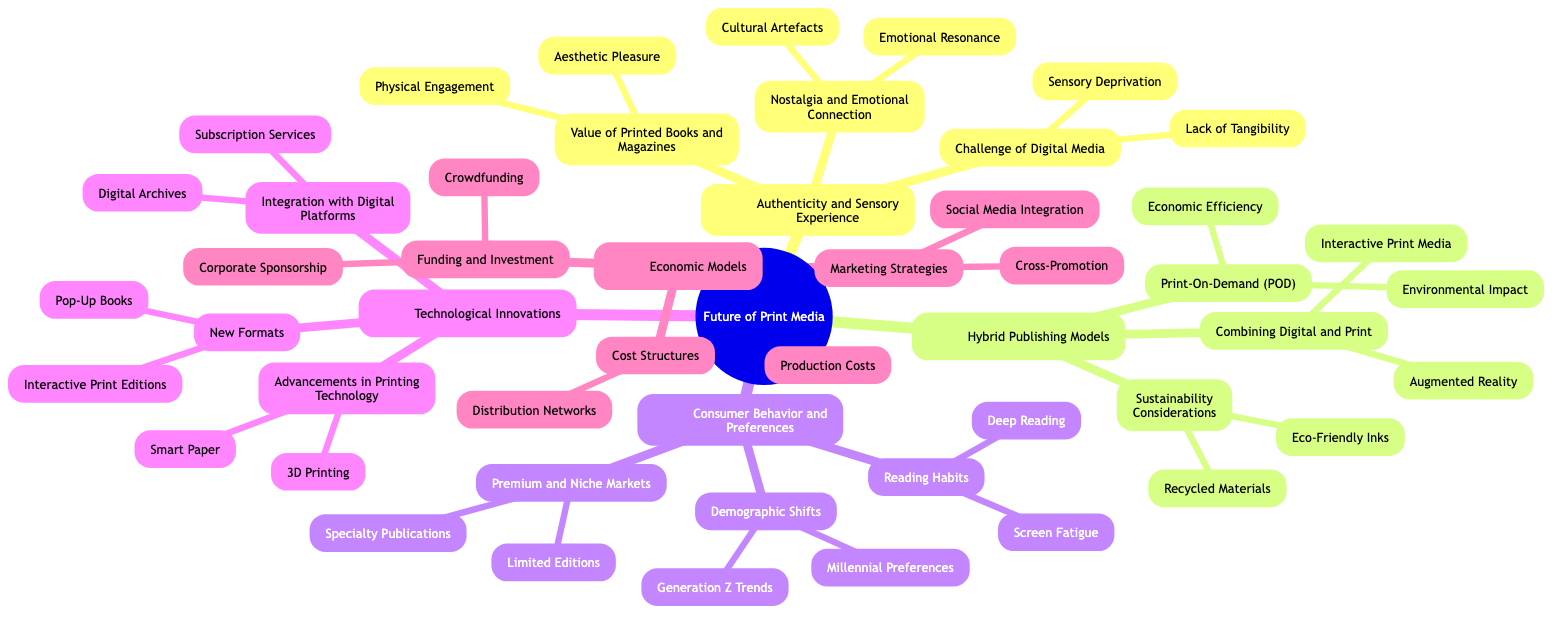What are the subelements under "Challenge of Digital Media"? The diagram shows the subelements beneath "Challenge of Digital Media" as "Lack of Tangibility" and "Sensory Deprivation".
Answer: Lack of Tangibility, Sensory Deprivation How many main categories does the concept map have? The concept map presents five main categories: Authenticity and Sensory Experience, Hybrid Publishing Models, Consumer Behavior and Preferences, Technological Innovations, and Economic Models, totaling five.
Answer: 5 What subcategory is associated with "Print-On-Demand (POD)"? The subcategory associated with "Print-On-Demand (POD)" is "Hybrid Publishing Models", which contains "Economic Efficiency" and "Environmental Impact" as its subelements.
Answer: Hybrid Publishing Models Which demographic group's preferences are highlighted in the diagram? The preferences of "Millennials" and "Generation Z" are highlighted under the "Demographic Shifts" subcategory within "Consumer Behavior and Preferences".
Answer: Millennials, Generation Z What technological advancement is listed under "Advancements in Printing Technology"? The diagram lists "3D Printing" and "Smart Paper" as advancements in printing technology under the "Technological Innovations" category.
Answer: 3D Printing, Smart Paper What is the purpose of integrating digital platforms with print media? The purpose of this integration, shown under "Integration with Digital Platforms", includes "Digital Archives" and "Subscription Services", indicating a blend of digital and print for accessibility and ongoing engagement.
Answer: Digital Archives, Subscription Services Name one subelement under "Sustainability Considerations". The diagram lists "Recycled Materials" and "Eco-Friendly Inks" as subelements under "Sustainability Considerations".
Answer: Recycled Materials What type of markets are indicated as premium and niche? The notion of "Limited Editions" and "Specialty Publications" is indicated as characteristic of premium and niche markets under "Premium and Niche Markets".
Answer: Limited Editions, Specialty Publications How is the consumer behavior regarding reading habits characterized in the diagram? Reading habits are characterized in the diagram by "Screen Fatigue" and "Deep Reading", showing a contrast in reading engagement preferences.
Answer: Screen Fatigue, Deep Reading 